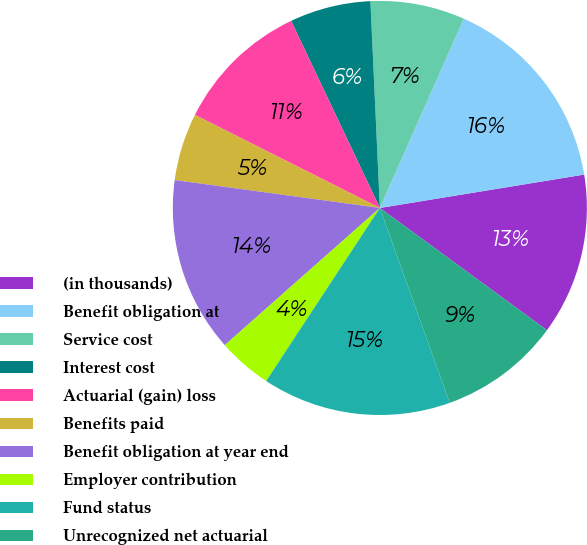Convert chart. <chart><loc_0><loc_0><loc_500><loc_500><pie_chart><fcel>(in thousands)<fcel>Benefit obligation at<fcel>Service cost<fcel>Interest cost<fcel>Actuarial (gain) loss<fcel>Benefits paid<fcel>Benefit obligation at year end<fcel>Employer contribution<fcel>Fund status<fcel>Unrecognized net actuarial<nl><fcel>12.63%<fcel>15.78%<fcel>7.37%<fcel>6.32%<fcel>10.53%<fcel>5.27%<fcel>13.68%<fcel>4.22%<fcel>14.73%<fcel>9.47%<nl></chart> 